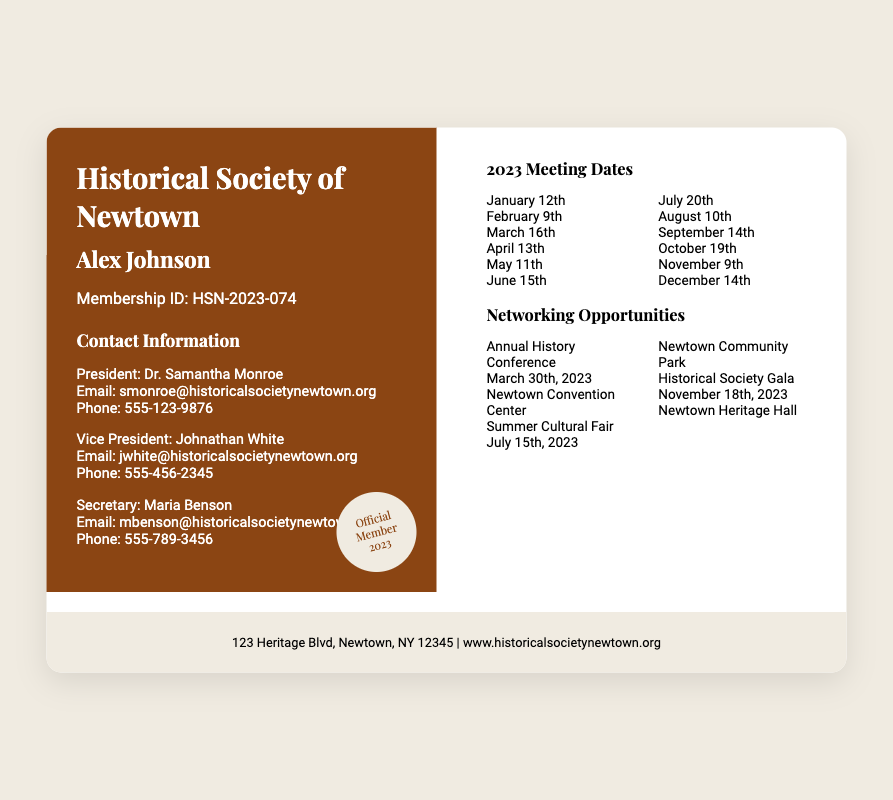What is the membership ID? The membership ID is specified in the member info section of the document.
Answer: HSN-2023-074 Who is the President of the Historical Society? The President's name is listed under the contact information.
Answer: Dr. Samantha Monroe What is the date of the Annual History Conference? The date is found in the networking opportunities section of the document.
Answer: March 30th, 2023 How many meeting dates are there in 2023? The number of meeting dates can be counted from the meeting dates section.
Answer: 12 Where is the Historical Society Gala being held? The location is provided in the networking opportunities section.
Answer: Newtown Heritage Hall What is the email address of the Secretary? This information is available in the contact information section.
Answer: mbenson@historicalsocietynewtown.org What color is the left side of the card? The left side's background color is described in the styling of the document.
Answer: Brown Which month does the last meeting occur? The last meeting's date is listed among the meeting dates.
Answer: December 